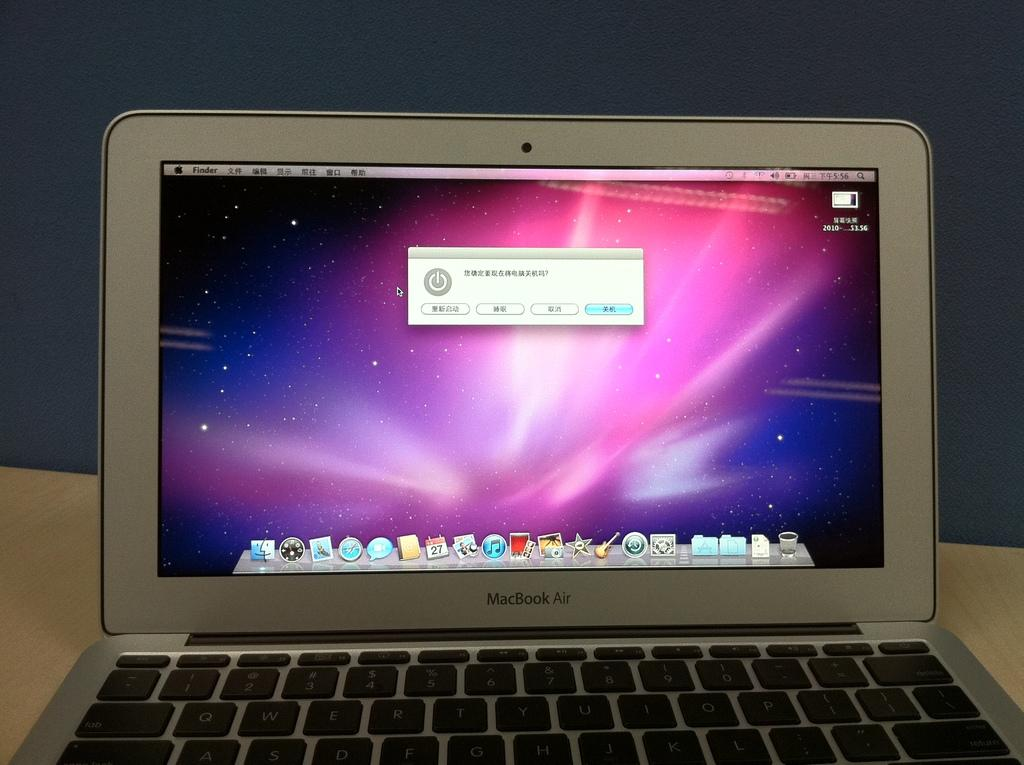<image>
Relay a brief, clear account of the picture shown. A Macbook Air displays the home screen with the dock at the bottom. 